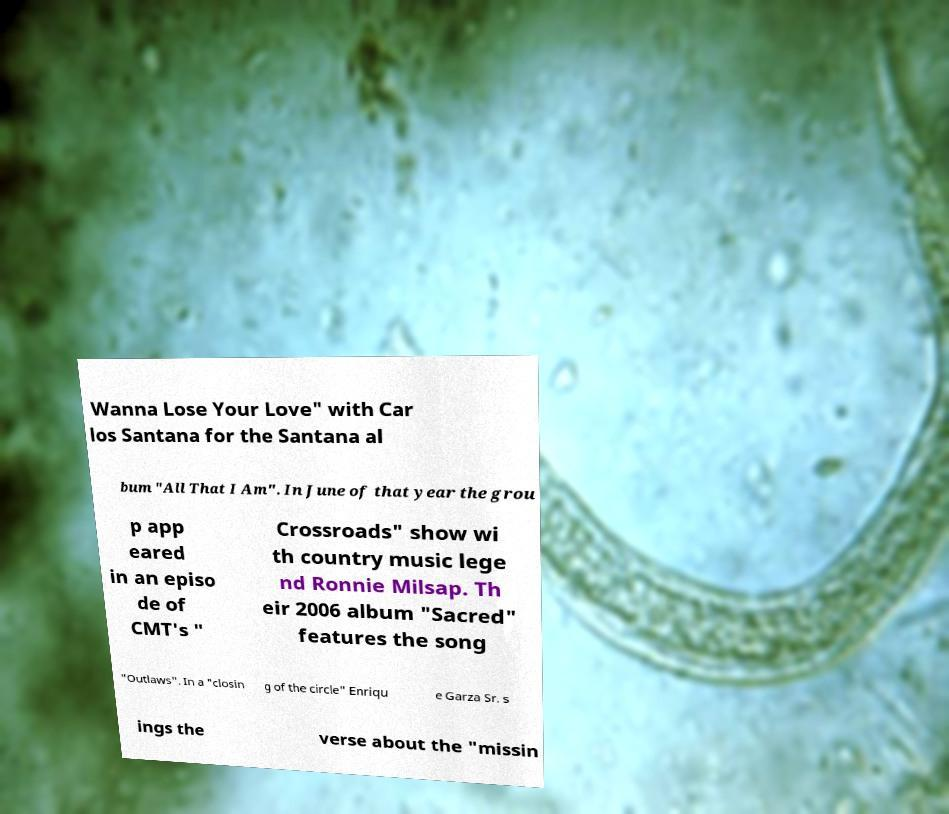For documentation purposes, I need the text within this image transcribed. Could you provide that? Wanna Lose Your Love" with Car los Santana for the Santana al bum "All That I Am". In June of that year the grou p app eared in an episo de of CMT's " Crossroads" show wi th country music lege nd Ronnie Milsap. Th eir 2006 album "Sacred" features the song "Outlaws". In a "closin g of the circle" Enriqu e Garza Sr. s ings the verse about the "missin 